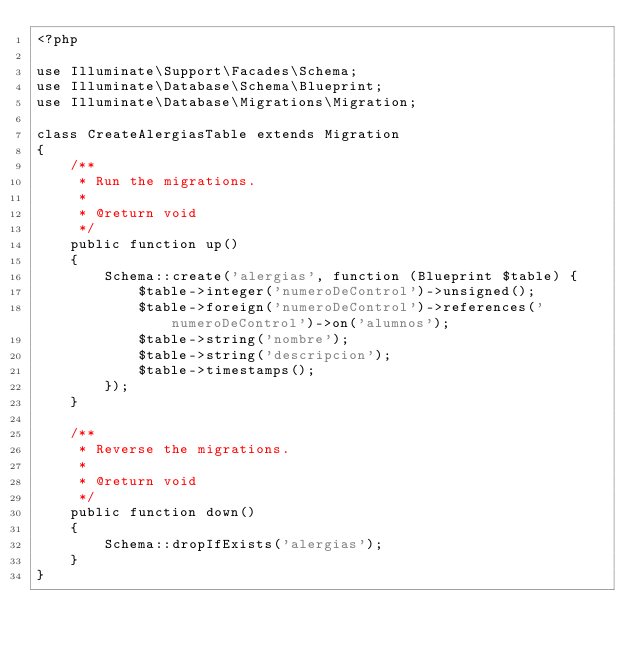<code> <loc_0><loc_0><loc_500><loc_500><_PHP_><?php

use Illuminate\Support\Facades\Schema;
use Illuminate\Database\Schema\Blueprint;
use Illuminate\Database\Migrations\Migration;

class CreateAlergiasTable extends Migration
{
    /**
     * Run the migrations.
     *
     * @return void
     */
    public function up()
    {
        Schema::create('alergias', function (Blueprint $table) {
            $table->integer('numeroDeControl')->unsigned();
            $table->foreign('numeroDeControl')->references('numeroDeControl')->on('alumnos');
            $table->string('nombre');
            $table->string('descripcion');
            $table->timestamps();
        });
    }

    /**
     * Reverse the migrations.
     *
     * @return void
     */
    public function down()
    {
        Schema::dropIfExists('alergias');
    }
}
</code> 